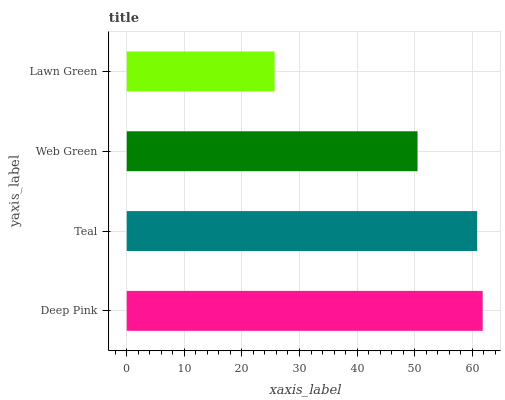Is Lawn Green the minimum?
Answer yes or no. Yes. Is Deep Pink the maximum?
Answer yes or no. Yes. Is Teal the minimum?
Answer yes or no. No. Is Teal the maximum?
Answer yes or no. No. Is Deep Pink greater than Teal?
Answer yes or no. Yes. Is Teal less than Deep Pink?
Answer yes or no. Yes. Is Teal greater than Deep Pink?
Answer yes or no. No. Is Deep Pink less than Teal?
Answer yes or no. No. Is Teal the high median?
Answer yes or no. Yes. Is Web Green the low median?
Answer yes or no. Yes. Is Deep Pink the high median?
Answer yes or no. No. Is Deep Pink the low median?
Answer yes or no. No. 